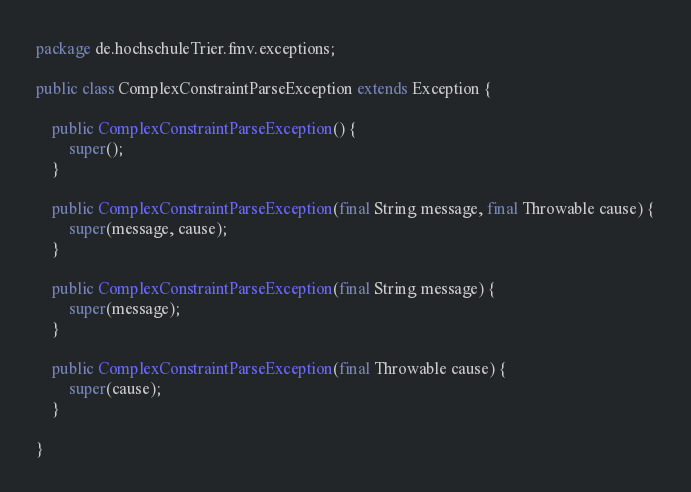Convert code to text. <code><loc_0><loc_0><loc_500><loc_500><_Java_>package de.hochschuleTrier.fmv.exceptions;

public class ComplexConstraintParseException extends Exception {

	public ComplexConstraintParseException() {
		super();
	}

	public ComplexConstraintParseException(final String message, final Throwable cause) {
		super(message, cause);
	}

	public ComplexConstraintParseException(final String message) {
		super(message);
	}

	public ComplexConstraintParseException(final Throwable cause) {
		super(cause);
	}

}
</code> 